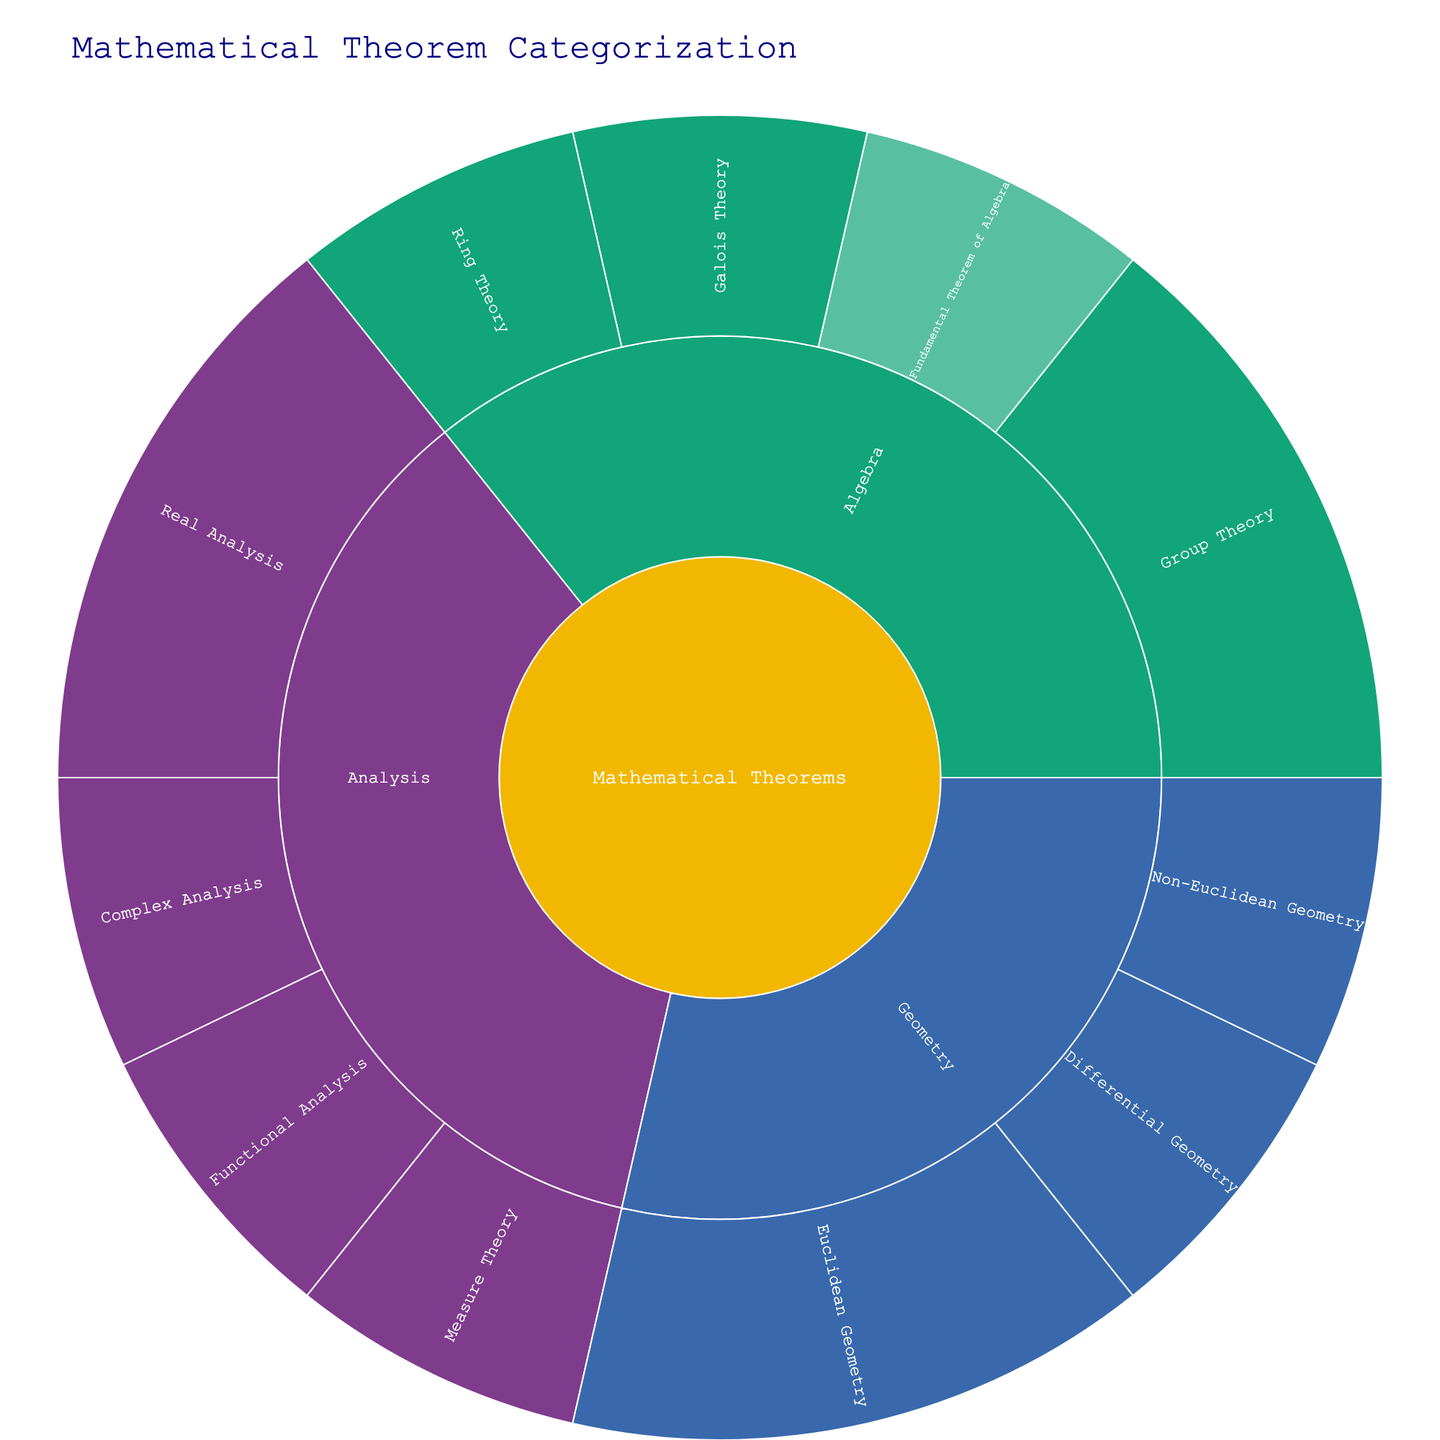What branches are depicted in the Sunburst Plot? The branches are depicted in the Sunburst Plot by the colors representing different major categories. In this plot, they are Algebra, Geometry, and Analysis. Each branch further divides into subcategories.
Answer: Algebra, Geometry, Analysis Which branch has the most specific theorems listed? To determine which branch has the most specific theorems, count the specific theorems under each branch. Algebra has 5 specific theorems, Geometry has 4 specific theorems, and Analysis has 5 specific theorems. The branches Algebra and Analysis exhibit the maximum specific theorems, both having 5.
Answer: Algebra and Analysis How many theorems are in the Algebra branch? By examining the Algebra branch, we observe that it contains several sub-branches and specific theorems. Counting these indicates there are 5 total theorems.
Answer: 5 What is the relation between the specific theorems and the root in the Sunburst Plot? The Sunburst Plot displays hierarchical relationships. The root, "Mathematical Theorems," connects to branches, which then connect to specific theorems. Each path from the center leads to specific theorems, showing how they originate from the root.
Answer: Hierarchical Relationship Are there more specific theorems in Real Analysis or Euclidean Geometry? Real Analysis, under Analysis, has two specific theorems: Intermediate Value Theorem and Extreme Value Theorem. Euclidean Geometry, under Geometry, also has two specific theorems: Pythagorean Theorem and Thales' Theorem. Both categories have an equal number of specific theorems.
Answer: Equal number (2 each) Which theorem is nested under Galois Theory? The plot visually shows the nested structure under branches. Galois Theory, within Algebra, has the Fundamental Theorem of Galois Theory nested under it.
Answer: Fundamental Theorem of Galois Theory What theorem lies within the Differential Geometry category? Differential Geometry, a sub-category within Geometry, consists of one specific theorem. Examining the plot shows it's the Poincaré Conjecture.
Answer: Poincaré Conjecture How do theorems in Functional Analysis compare to those in Measure Theory? Functional Analysis in the Analysis branch has the Hahn-Banach Theorem. Measure Theory also under Analysis has the Lebesgue Differentiation Theorem. Each sub-branch contains one specific theorem.
Answer: Same amount (1 each) What is the shared characteristic of the theorems in Group Theory? Observing the Group Theory sub-branch under Algebra, it contains Lagrange's Theorem and Sylow Theorems. Both theorems are part of the study of groups within algebra.
Answer: Study of Groups Can you determine the color scheme used to differentiate branches in the plot? The color scheme in the Sunburst Plot differentiates branches by providing distinct colors from a predefined palette. The specific colors separate Algebra, Geometry, and Analysis clearly. This enhances visual differentiation but exact colors depend on the predefined palette applied.
Answer: Distinctive and predefined color scheme 